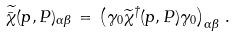<formula> <loc_0><loc_0><loc_500><loc_500>\widetilde { \bar { \chi } } ( p , P ) _ { \alpha \beta } \, = \, \left ( \gamma _ { 0 } \widetilde { \chi } ^ { \dagger } ( p , P ) \gamma _ { 0 } \right ) _ { \alpha \beta } \, .</formula> 